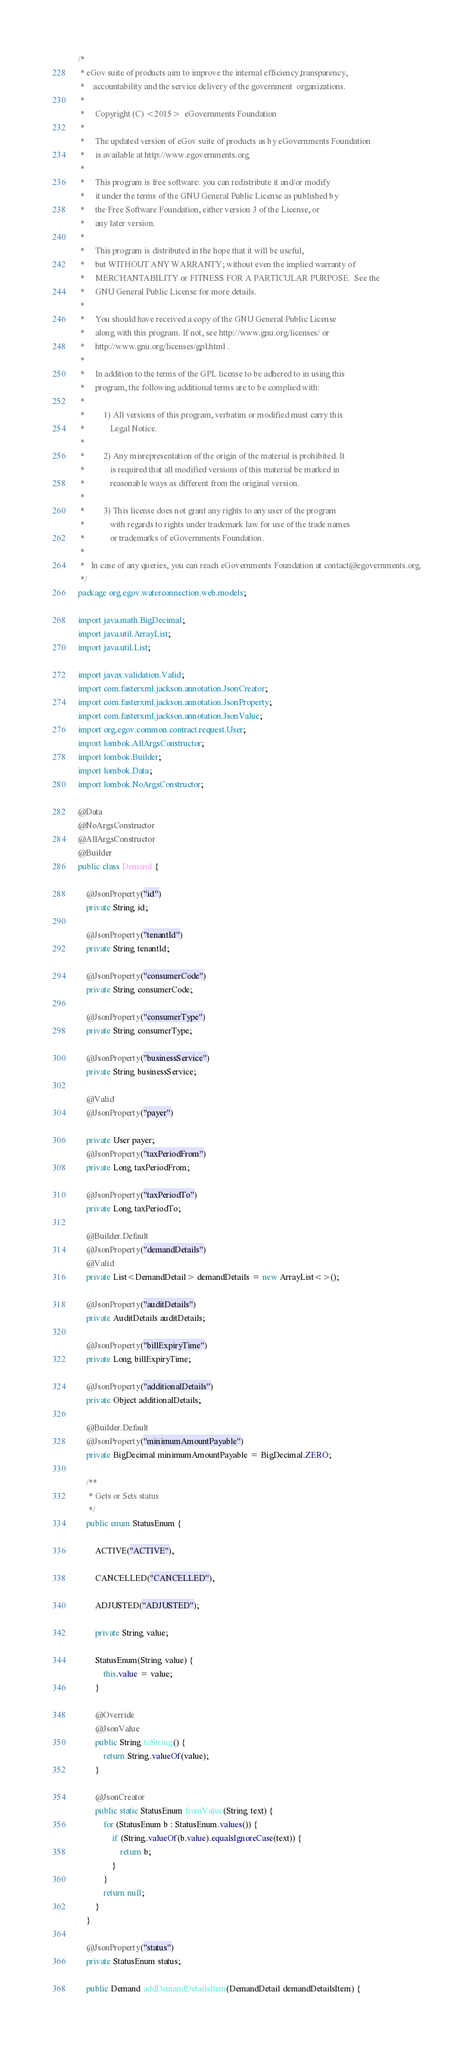Convert code to text. <code><loc_0><loc_0><loc_500><loc_500><_Java_>/*
 * eGov suite of products aim to improve the internal efficiency,transparency,
 *    accountability and the service delivery of the government  organizations.
 *
 *     Copyright (C) <2015>  eGovernments Foundation
 *
 *     The updated version of eGov suite of products as by eGovernments Foundation
 *     is available at http://www.egovernments.org
 *
 *     This program is free software: you can redistribute it and/or modify
 *     it under the terms of the GNU General Public License as published by
 *     the Free Software Foundation, either version 3 of the License, or
 *     any later version.
 *
 *     This program is distributed in the hope that it will be useful,
 *     but WITHOUT ANY WARRANTY; without even the implied warranty of
 *     MERCHANTABILITY or FITNESS FOR A PARTICULAR PURPOSE.  See the
 *     GNU General Public License for more details.
 *
 *     You should have received a copy of the GNU General Public License
 *     along with this program. If not, see http://www.gnu.org/licenses/ or
 *     http://www.gnu.org/licenses/gpl.html .
 *
 *     In addition to the terms of the GPL license to be adhered to in using this
 *     program, the following additional terms are to be complied with:
 *
 *         1) All versions of this program, verbatim or modified must carry this
 *            Legal Notice.
 *
 *         2) Any misrepresentation of the origin of the material is prohibited. It
 *            is required that all modified versions of this material be marked in
 *            reasonable ways as different from the original version.
 *
 *         3) This license does not grant any rights to any user of the program
 *            with regards to rights under trademark law for use of the trade names
 *            or trademarks of eGovernments Foundation.
 *
 *   In case of any queries, you can reach eGovernments Foundation at contact@egovernments.org.
 */
package org.egov.waterconnection.web.models;

import java.math.BigDecimal;
import java.util.ArrayList;
import java.util.List;

import javax.validation.Valid;
import com.fasterxml.jackson.annotation.JsonCreator;
import com.fasterxml.jackson.annotation.JsonProperty;
import com.fasterxml.jackson.annotation.JsonValue;
import org.egov.common.contract.request.User;
import lombok.AllArgsConstructor;
import lombok.Builder;
import lombok.Data;
import lombok.NoArgsConstructor;

@Data
@NoArgsConstructor
@AllArgsConstructor
@Builder
public class Demand {

	@JsonProperty("id")
	private String id;

	@JsonProperty("tenantId")
	private String tenantId;

	@JsonProperty("consumerCode")
	private String consumerCode;

	@JsonProperty("consumerType")
	private String consumerType;

	@JsonProperty("businessService")
	private String businessService;

	@Valid
	@JsonProperty("payer")

	private User payer;
	@JsonProperty("taxPeriodFrom")
	private Long taxPeriodFrom;

	@JsonProperty("taxPeriodTo")
	private Long taxPeriodTo;

	@Builder.Default
	@JsonProperty("demandDetails")
	@Valid
	private List<DemandDetail> demandDetails = new ArrayList<>();

	@JsonProperty("auditDetails")
	private AuditDetails auditDetails;

	@JsonProperty("billExpiryTime")
	private Long billExpiryTime;

	@JsonProperty("additionalDetails")
	private Object additionalDetails;

	@Builder.Default
	@JsonProperty("minimumAmountPayable")
	private BigDecimal minimumAmountPayable = BigDecimal.ZERO;

	/**
	 * Gets or Sets status
	 */
	public enum StatusEnum {

		ACTIVE("ACTIVE"),

		CANCELLED("CANCELLED"),

		ADJUSTED("ADJUSTED");

		private String value;

		StatusEnum(String value) {
			this.value = value;
		}

		@Override
		@JsonValue
		public String toString() {
			return String.valueOf(value);
		}

		@JsonCreator
		public static StatusEnum fromValue(String text) {
			for (StatusEnum b : StatusEnum.values()) {
				if (String.valueOf(b.value).equalsIgnoreCase(text)) {
					return b;
				}
			}
			return null;
		}
	}

	@JsonProperty("status")
	private StatusEnum status;

	public Demand addDemandDetailsItem(DemandDetail demandDetailsItem) {</code> 